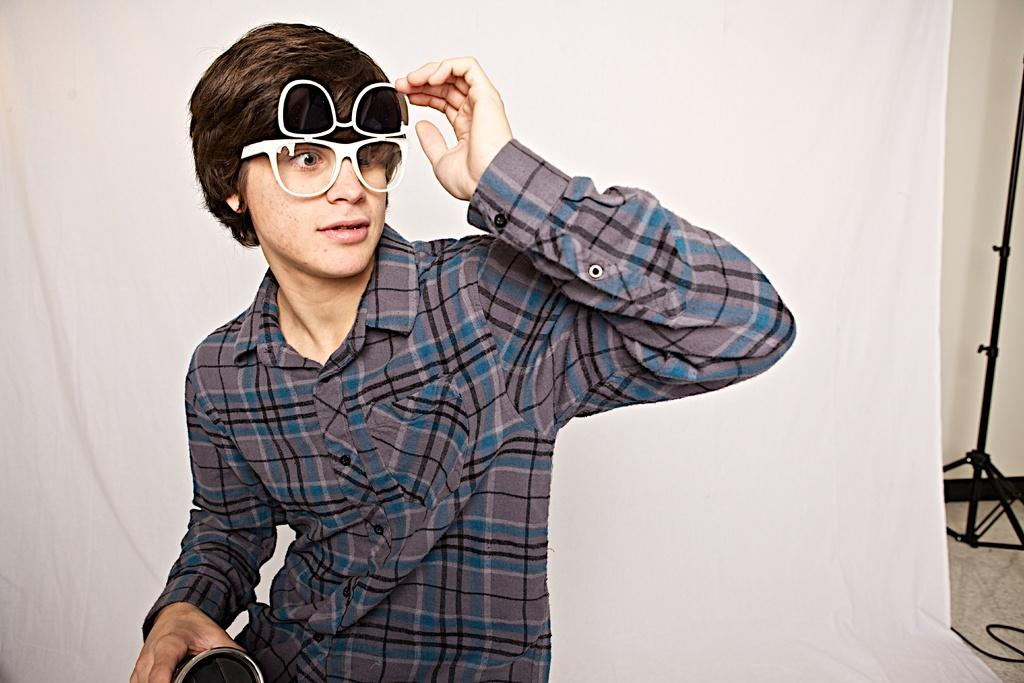What is the main subject of the image? There is a man in the image. Can you describe the man's appearance? The man is wearing clothes and spectacles. What else can be seen in the image besides the man? There is a white cloth, a cable wire, a floor, a stand, and a cable wire in the image. What is the man holding in his hand? The man is holding an object in his hand. How does the man compare to a cub in the image? There is no cub present in the image, so it is not possible to make a comparison between the man and a cub. 